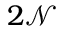Convert formula to latex. <formula><loc_0><loc_0><loc_500><loc_500>2 \mathcal { N }</formula> 